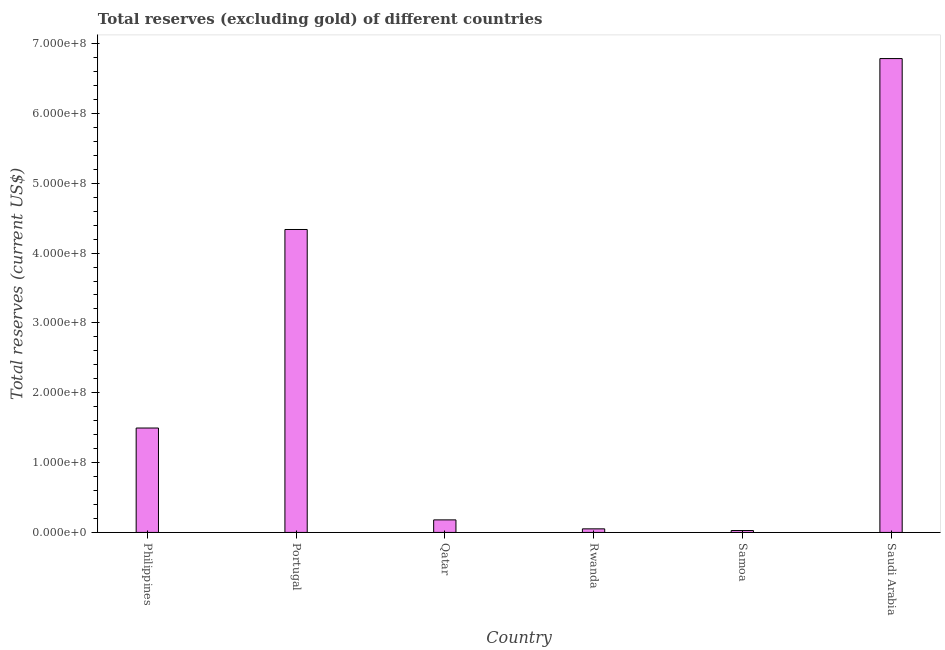Does the graph contain grids?
Your response must be concise. No. What is the title of the graph?
Make the answer very short. Total reserves (excluding gold) of different countries. What is the label or title of the X-axis?
Your response must be concise. Country. What is the label or title of the Y-axis?
Make the answer very short. Total reserves (current US$). What is the total reserves (excluding gold) in Qatar?
Your answer should be compact. 1.80e+07. Across all countries, what is the maximum total reserves (excluding gold)?
Ensure brevity in your answer.  6.78e+08. Across all countries, what is the minimum total reserves (excluding gold)?
Keep it short and to the point. 2.73e+06. In which country was the total reserves (excluding gold) maximum?
Provide a short and direct response. Saudi Arabia. In which country was the total reserves (excluding gold) minimum?
Offer a terse response. Samoa. What is the sum of the total reserves (excluding gold)?
Provide a short and direct response. 1.29e+09. What is the difference between the total reserves (excluding gold) in Portugal and Saudi Arabia?
Keep it short and to the point. -2.45e+08. What is the average total reserves (excluding gold) per country?
Your response must be concise. 2.15e+08. What is the median total reserves (excluding gold)?
Ensure brevity in your answer.  8.37e+07. In how many countries, is the total reserves (excluding gold) greater than 140000000 US$?
Offer a very short reply. 3. What is the ratio of the total reserves (excluding gold) in Philippines to that in Rwanda?
Make the answer very short. 29.14. Is the difference between the total reserves (excluding gold) in Qatar and Rwanda greater than the difference between any two countries?
Provide a succinct answer. No. What is the difference between the highest and the second highest total reserves (excluding gold)?
Ensure brevity in your answer.  2.45e+08. What is the difference between the highest and the lowest total reserves (excluding gold)?
Ensure brevity in your answer.  6.76e+08. How many bars are there?
Offer a terse response. 6. How many countries are there in the graph?
Offer a very short reply. 6. What is the difference between two consecutive major ticks on the Y-axis?
Give a very brief answer. 1.00e+08. Are the values on the major ticks of Y-axis written in scientific E-notation?
Provide a succinct answer. Yes. What is the Total reserves (current US$) of Philippines?
Provide a succinct answer. 1.49e+08. What is the Total reserves (current US$) of Portugal?
Offer a terse response. 4.34e+08. What is the Total reserves (current US$) of Qatar?
Your response must be concise. 1.80e+07. What is the Total reserves (current US$) of Rwanda?
Your response must be concise. 5.13e+06. What is the Total reserves (current US$) of Samoa?
Keep it short and to the point. 2.73e+06. What is the Total reserves (current US$) of Saudi Arabia?
Ensure brevity in your answer.  6.78e+08. What is the difference between the Total reserves (current US$) in Philippines and Portugal?
Your answer should be very brief. -2.84e+08. What is the difference between the Total reserves (current US$) in Philippines and Qatar?
Provide a succinct answer. 1.32e+08. What is the difference between the Total reserves (current US$) in Philippines and Rwanda?
Offer a very short reply. 1.44e+08. What is the difference between the Total reserves (current US$) in Philippines and Samoa?
Your answer should be very brief. 1.47e+08. What is the difference between the Total reserves (current US$) in Philippines and Saudi Arabia?
Offer a terse response. -5.29e+08. What is the difference between the Total reserves (current US$) in Portugal and Qatar?
Ensure brevity in your answer.  4.16e+08. What is the difference between the Total reserves (current US$) in Portugal and Rwanda?
Offer a very short reply. 4.29e+08. What is the difference between the Total reserves (current US$) in Portugal and Samoa?
Give a very brief answer. 4.31e+08. What is the difference between the Total reserves (current US$) in Portugal and Saudi Arabia?
Make the answer very short. -2.45e+08. What is the difference between the Total reserves (current US$) in Qatar and Rwanda?
Offer a terse response. 1.28e+07. What is the difference between the Total reserves (current US$) in Qatar and Samoa?
Make the answer very short. 1.52e+07. What is the difference between the Total reserves (current US$) in Qatar and Saudi Arabia?
Ensure brevity in your answer.  -6.61e+08. What is the difference between the Total reserves (current US$) in Rwanda and Samoa?
Give a very brief answer. 2.40e+06. What is the difference between the Total reserves (current US$) in Rwanda and Saudi Arabia?
Your answer should be compact. -6.73e+08. What is the difference between the Total reserves (current US$) in Samoa and Saudi Arabia?
Offer a terse response. -6.76e+08. What is the ratio of the Total reserves (current US$) in Philippines to that in Portugal?
Your response must be concise. 0.34. What is the ratio of the Total reserves (current US$) in Philippines to that in Qatar?
Give a very brief answer. 8.32. What is the ratio of the Total reserves (current US$) in Philippines to that in Rwanda?
Offer a terse response. 29.14. What is the ratio of the Total reserves (current US$) in Philippines to that in Samoa?
Provide a short and direct response. 54.76. What is the ratio of the Total reserves (current US$) in Philippines to that in Saudi Arabia?
Keep it short and to the point. 0.22. What is the ratio of the Total reserves (current US$) in Portugal to that in Qatar?
Keep it short and to the point. 24.13. What is the ratio of the Total reserves (current US$) in Portugal to that in Rwanda?
Offer a terse response. 84.55. What is the ratio of the Total reserves (current US$) in Portugal to that in Samoa?
Keep it short and to the point. 158.89. What is the ratio of the Total reserves (current US$) in Portugal to that in Saudi Arabia?
Make the answer very short. 0.64. What is the ratio of the Total reserves (current US$) in Qatar to that in Rwanda?
Provide a short and direct response. 3.5. What is the ratio of the Total reserves (current US$) in Qatar to that in Samoa?
Provide a short and direct response. 6.58. What is the ratio of the Total reserves (current US$) in Qatar to that in Saudi Arabia?
Your response must be concise. 0.03. What is the ratio of the Total reserves (current US$) in Rwanda to that in Samoa?
Offer a terse response. 1.88. What is the ratio of the Total reserves (current US$) in Rwanda to that in Saudi Arabia?
Provide a short and direct response. 0.01. What is the ratio of the Total reserves (current US$) in Samoa to that in Saudi Arabia?
Offer a very short reply. 0. 